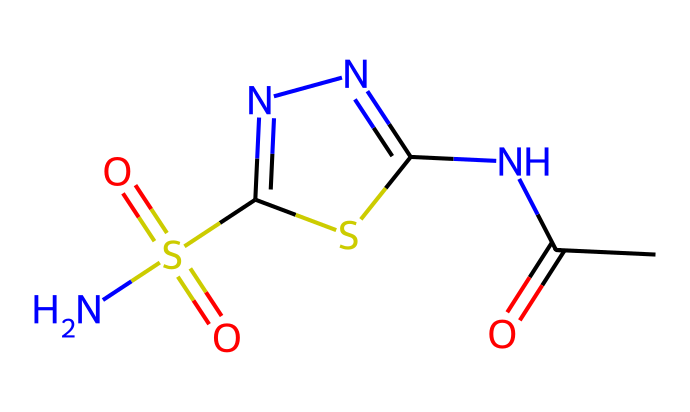What is the molecular formula of acetazolamide? By analyzing the SMILES representation, we can identify the number of each type of atom present. Counting them yields: C = 4, H = 6, N = 4, O = 3, S = 2. This gives us the molecular formula: C4H6N4O3S2.
Answer: C4H6N4O3S2 How many nitrogen atoms are in acetazolamide? By inspecting the molecular structure through its SMILES representation, we find that there are four occurrences of nitrogen (N).
Answer: 4 What functional groups are found in acetazolamide? The SMILES representation indicates the presence of an amide group (CC(=O)N) and sulfonamide group (S(=O)(=O)N). These can be distinguished from the rest of the structure by their characteristic bonding patterns.
Answer: amide and sulfonamide What is the significance of the sulfonamide group in acetazolamide? The sulfonamide group (S(=O)(=O)N) plays a crucial role in the medication's mechanism of action. It is often responsible for the pharmacological activity in drugs that inhibit carbonic anhydrase, which is important in preventing altitude sickness.
Answer: carbonic anhydrase inhibition What type of medication is acetazolamide? Considering the structure and known uses of acetazolamide, it is categorized as a diuretic and carbonic anhydrase inhibitor, primarily used to prevent and treat altitude sickness.
Answer: diuretic and carbonic anhydrase inhibitor What is the total number of sulfate groups in acetazolamide? In the SMILES representation, we count one sulfonamide group, which has a sulfonic acid structure, indicating a sulfate entity present.
Answer: 1 